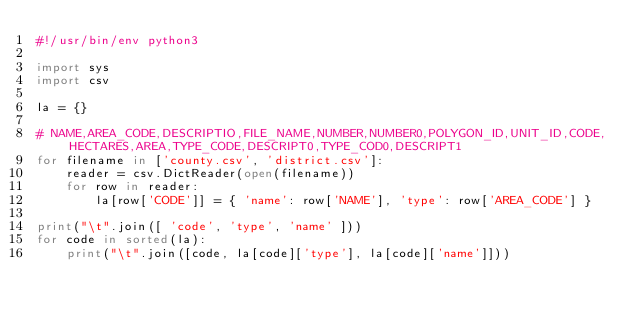<code> <loc_0><loc_0><loc_500><loc_500><_Python_>#!/usr/bin/env python3

import sys
import csv

la = {}

# NAME,AREA_CODE,DESCRIPTIO,FILE_NAME,NUMBER,NUMBER0,POLYGON_ID,UNIT_ID,CODE,HECTARES,AREA,TYPE_CODE,DESCRIPT0,TYPE_COD0,DESCRIPT1
for filename in ['county.csv', 'district.csv']:
    reader = csv.DictReader(open(filename))
    for row in reader:
        la[row['CODE']] = { 'name': row['NAME'], 'type': row['AREA_CODE'] }

print("\t".join([ 'code', 'type', 'name' ]))
for code in sorted(la):
    print("\t".join([code, la[code]['type'], la[code]['name']]))
</code> 